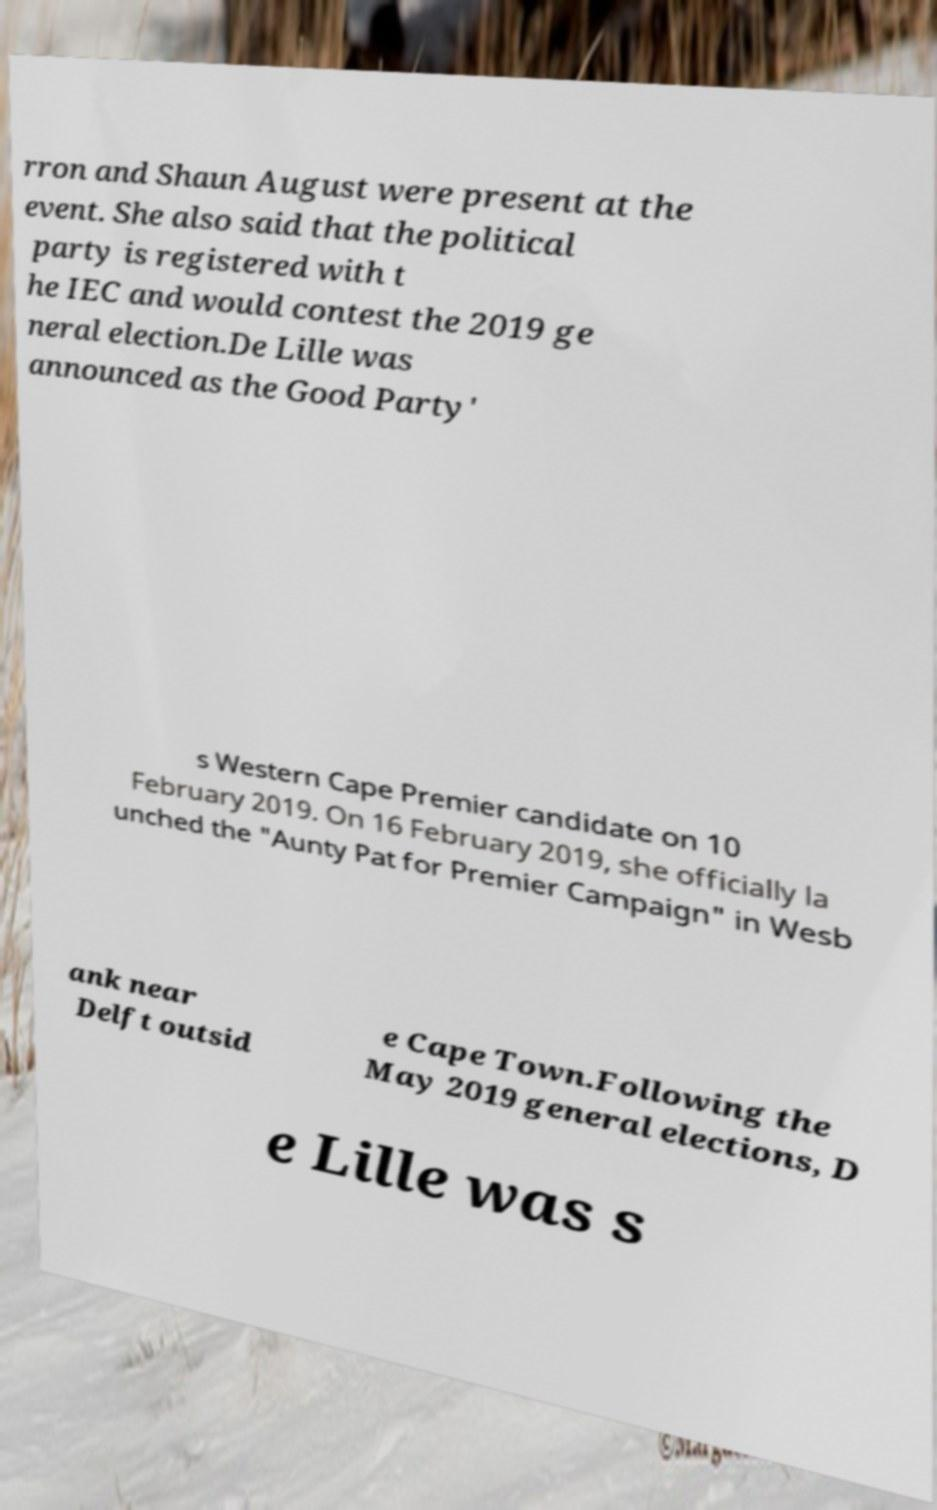For documentation purposes, I need the text within this image transcribed. Could you provide that? rron and Shaun August were present at the event. She also said that the political party is registered with t he IEC and would contest the 2019 ge neral election.De Lille was announced as the Good Party' s Western Cape Premier candidate on 10 February 2019. On 16 February 2019, she officially la unched the "Aunty Pat for Premier Campaign" in Wesb ank near Delft outsid e Cape Town.Following the May 2019 general elections, D e Lille was s 